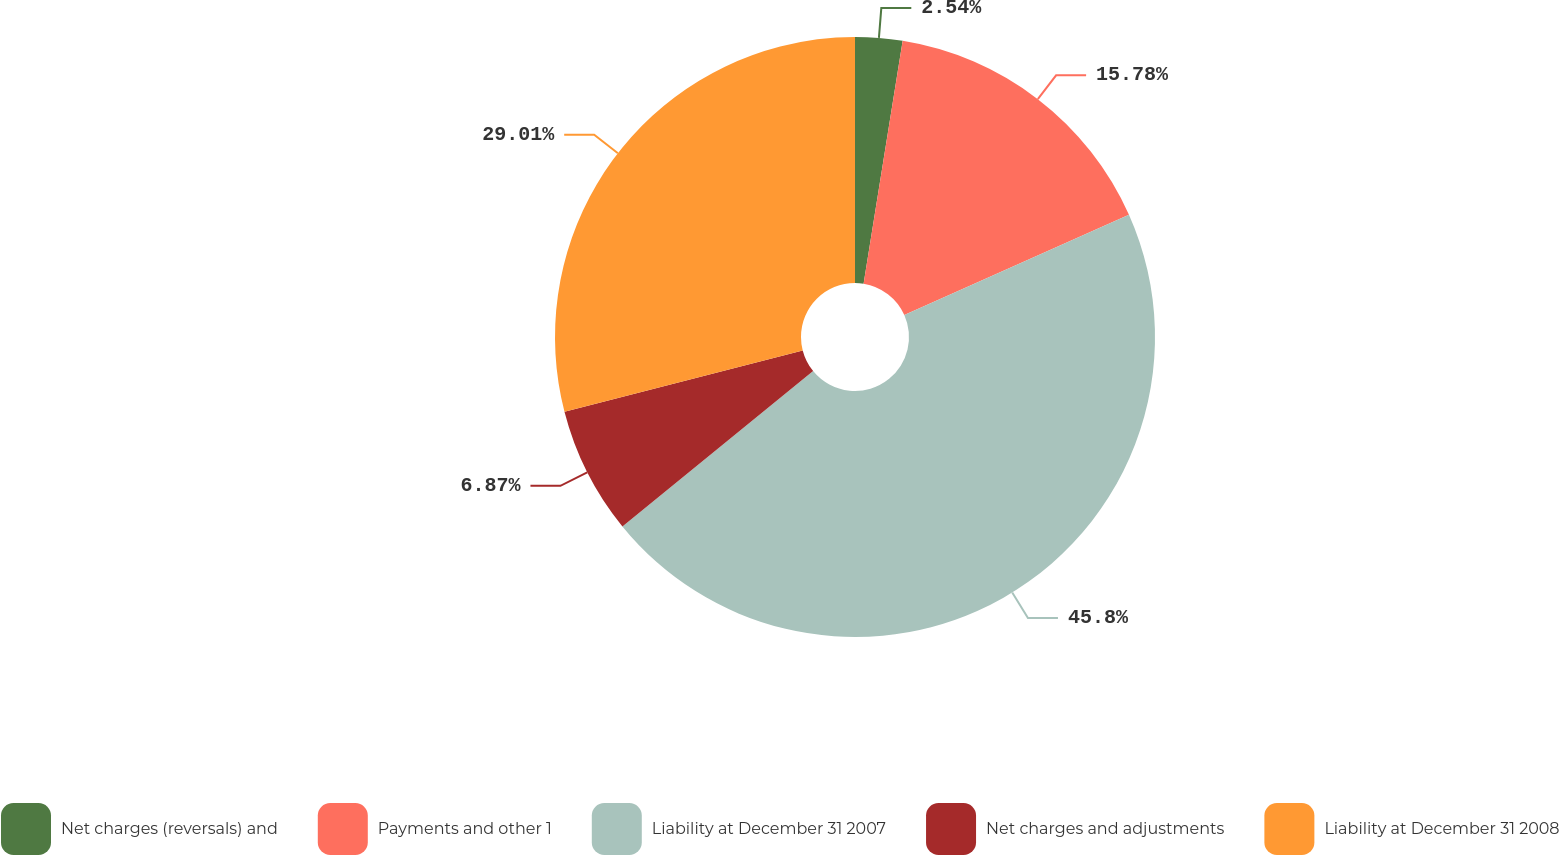Convert chart to OTSL. <chart><loc_0><loc_0><loc_500><loc_500><pie_chart><fcel>Net charges (reversals) and<fcel>Payments and other 1<fcel>Liability at December 31 2007<fcel>Net charges and adjustments<fcel>Liability at December 31 2008<nl><fcel>2.54%<fcel>15.78%<fcel>45.8%<fcel>6.87%<fcel>29.01%<nl></chart> 